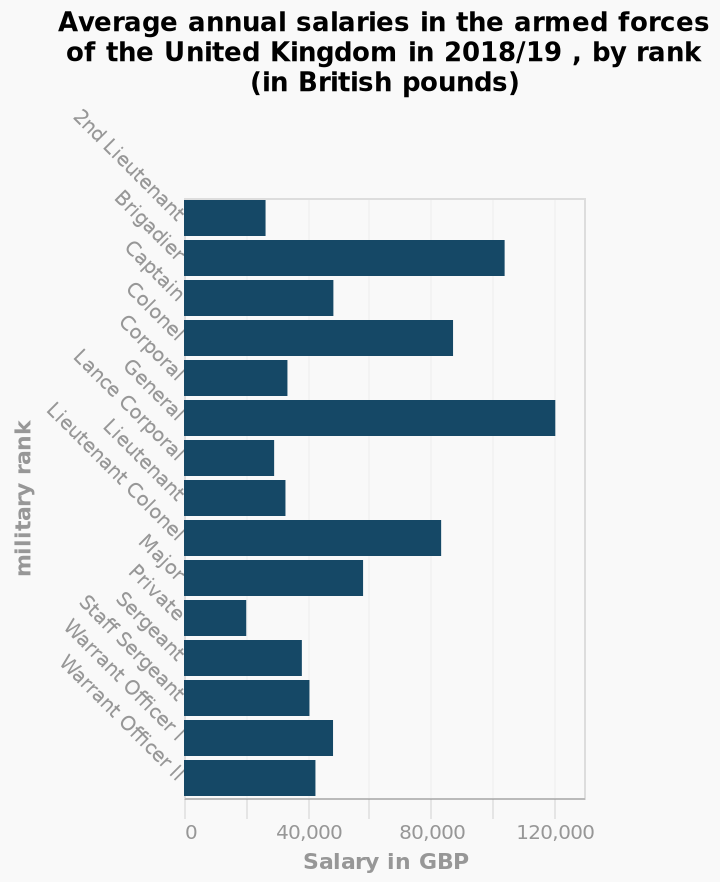<image>
What does the y-axis represent in the bar plot? The y-axis represents the military ranks in the armed forces of the United Kingdom, ranging from 2nd Lieutenant to Warrant Officer ll. What is the year covered by the data in the bar plot? The data in the bar plot represents the average annual salaries in the armed forces of the United Kingdom for the year 2018/19. What does the x-axis represent in the bar plot? The x-axis represents the average annual salaries in British pounds (GBP). Does the y-axis represent the average annual salaries in British pounds (GBP)? No.The x-axis represents the average annual salaries in British pounds (GBP). 